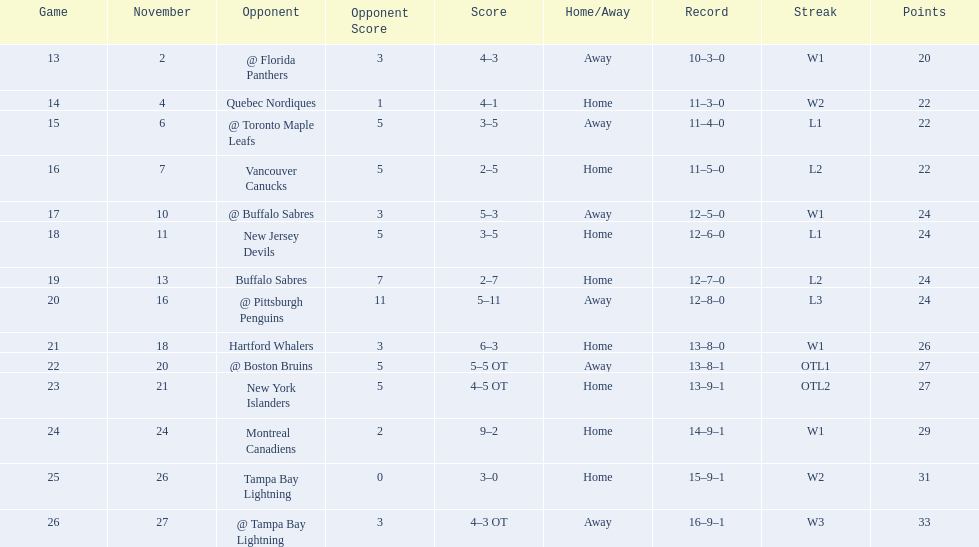Who are all of the teams? @ Florida Panthers, Quebec Nordiques, @ Toronto Maple Leafs, Vancouver Canucks, @ Buffalo Sabres, New Jersey Devils, Buffalo Sabres, @ Pittsburgh Penguins, Hartford Whalers, @ Boston Bruins, New York Islanders, Montreal Canadiens, Tampa Bay Lightning. What games finished in overtime? 22, 23, 26. In game number 23, who did they face? New York Islanders. 